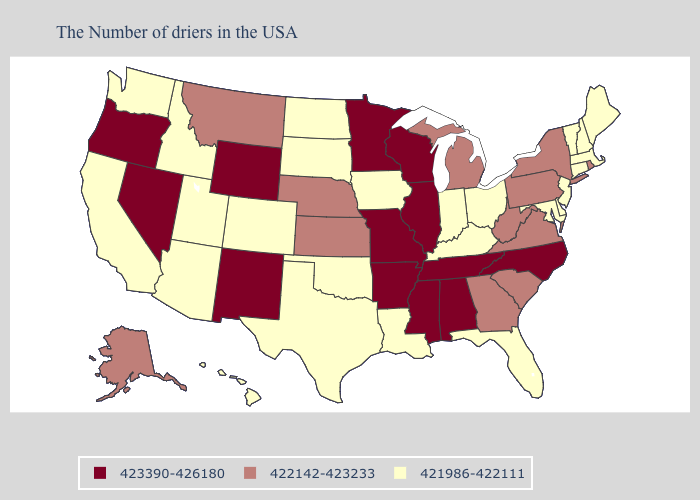Does Minnesota have the same value as Indiana?
Short answer required. No. Name the states that have a value in the range 421986-422111?
Give a very brief answer. Maine, Massachusetts, New Hampshire, Vermont, Connecticut, New Jersey, Delaware, Maryland, Ohio, Florida, Kentucky, Indiana, Louisiana, Iowa, Oklahoma, Texas, South Dakota, North Dakota, Colorado, Utah, Arizona, Idaho, California, Washington, Hawaii. What is the value of Utah?
Keep it brief. 421986-422111. Among the states that border Maryland , which have the highest value?
Be succinct. Pennsylvania, Virginia, West Virginia. What is the highest value in the USA?
Short answer required. 423390-426180. Name the states that have a value in the range 421986-422111?
Keep it brief. Maine, Massachusetts, New Hampshire, Vermont, Connecticut, New Jersey, Delaware, Maryland, Ohio, Florida, Kentucky, Indiana, Louisiana, Iowa, Oklahoma, Texas, South Dakota, North Dakota, Colorado, Utah, Arizona, Idaho, California, Washington, Hawaii. What is the value of New Mexico?
Short answer required. 423390-426180. What is the lowest value in the USA?
Quick response, please. 421986-422111. Does the first symbol in the legend represent the smallest category?
Be succinct. No. What is the value of Rhode Island?
Keep it brief. 422142-423233. Which states have the lowest value in the MidWest?
Write a very short answer. Ohio, Indiana, Iowa, South Dakota, North Dakota. Name the states that have a value in the range 422142-423233?
Write a very short answer. Rhode Island, New York, Pennsylvania, Virginia, South Carolina, West Virginia, Georgia, Michigan, Kansas, Nebraska, Montana, Alaska. Which states have the lowest value in the Northeast?
Concise answer only. Maine, Massachusetts, New Hampshire, Vermont, Connecticut, New Jersey. Name the states that have a value in the range 423390-426180?
Write a very short answer. North Carolina, Alabama, Tennessee, Wisconsin, Illinois, Mississippi, Missouri, Arkansas, Minnesota, Wyoming, New Mexico, Nevada, Oregon. Among the states that border Pennsylvania , which have the lowest value?
Quick response, please. New Jersey, Delaware, Maryland, Ohio. 